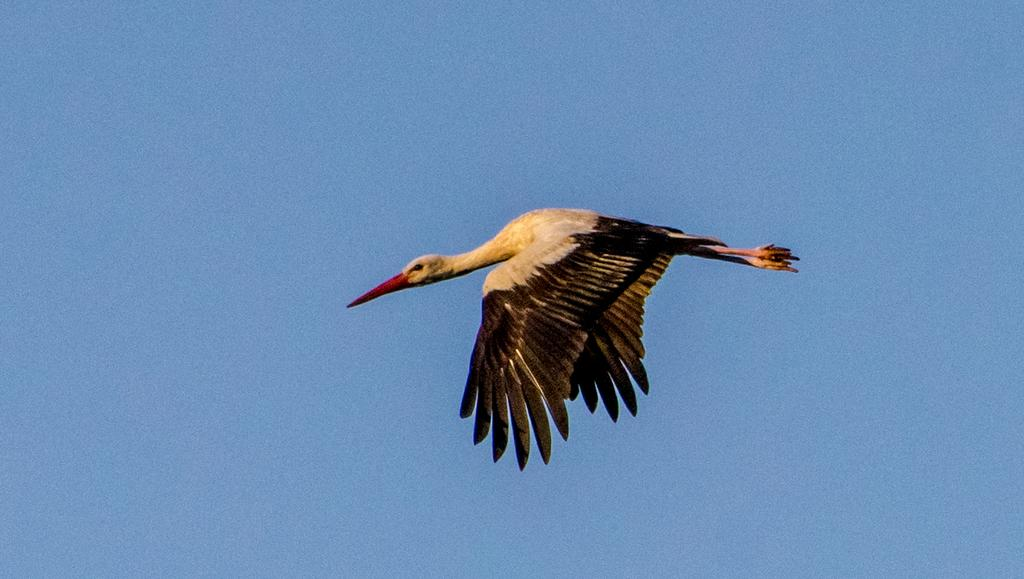What type of animal can be seen in the image? There is a bird in the image. What is the bird doing in the image? The bird is flying in the air. What can be seen in the background of the image? The sky is visible in the background of the image. What is the color of the sky in the image? The color of the sky is blue. Is the bird's friend wearing a mask in the image? There is no friend or mask present in the image; it only features a bird flying in the blue sky. 